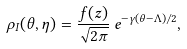<formula> <loc_0><loc_0><loc_500><loc_500>\rho _ { I } ( \theta , \eta ) = \frac { f ( z ) } { \sqrt { 2 \pi } } \, e ^ { - \gamma ( \theta - \Lambda ) / 2 } ,</formula> 